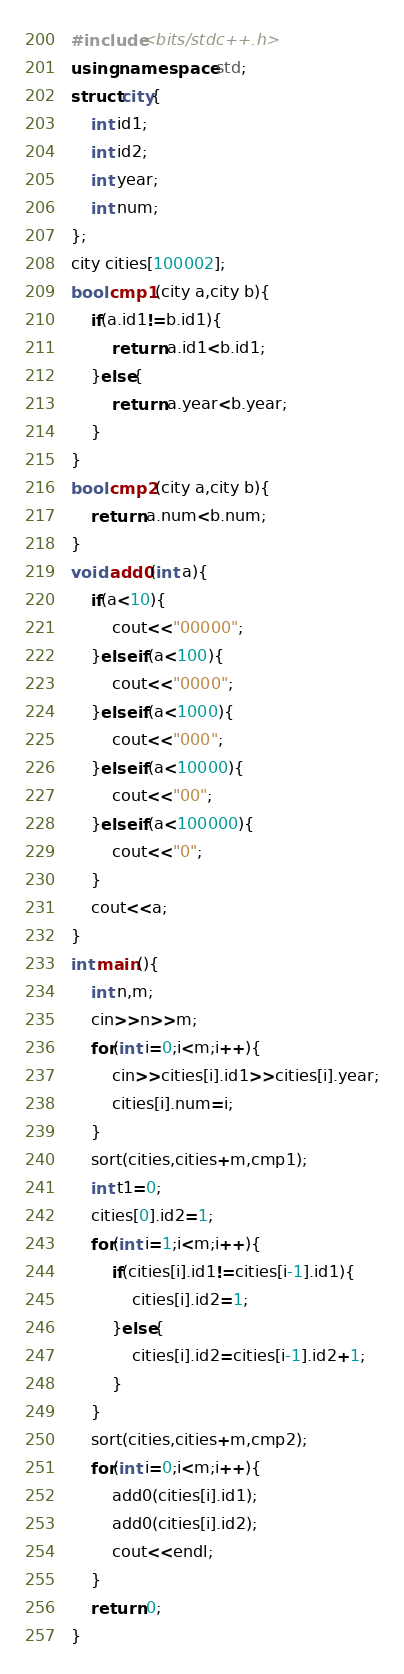<code> <loc_0><loc_0><loc_500><loc_500><_C++_>#include<bits/stdc++.h>
using namespace std;
struct city{
	int id1;
	int id2;
	int year;
	int num;
};
city cities[100002];
bool cmp1(city a,city b){
	if(a.id1!=b.id1){
		return a.id1<b.id1;
	}else{
		return a.year<b.year;
	}
}
bool cmp2(city a,city b){
	return a.num<b.num;
}
void add0(int a){
	if(a<10){
		cout<<"00000";
	}else if(a<100){
		cout<<"0000";
	}else if(a<1000){
		cout<<"000";
	}else if(a<10000){
		cout<<"00";
	}else if(a<100000){
		cout<<"0";
	}
	cout<<a;
}
int main(){
	int n,m;
	cin>>n>>m;
	for(int i=0;i<m;i++){
		cin>>cities[i].id1>>cities[i].year;
		cities[i].num=i;
	}
	sort(cities,cities+m,cmp1);
	int t1=0;
	cities[0].id2=1;
	for(int i=1;i<m;i++){
		if(cities[i].id1!=cities[i-1].id1){
			cities[i].id2=1;
		}else{
			cities[i].id2=cities[i-1].id2+1;
		}
	}
	sort(cities,cities+m,cmp2);
	for(int i=0;i<m;i++){
		add0(cities[i].id1);
		add0(cities[i].id2);
		cout<<endl;
	}
	return 0;
}</code> 